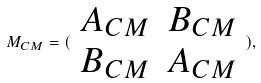<formula> <loc_0><loc_0><loc_500><loc_500>M _ { C M } = ( \begin{array} { c c } A _ { C M } & B _ { C M } \\ B _ { C M } & A _ { C M } \end{array} ) ,</formula> 